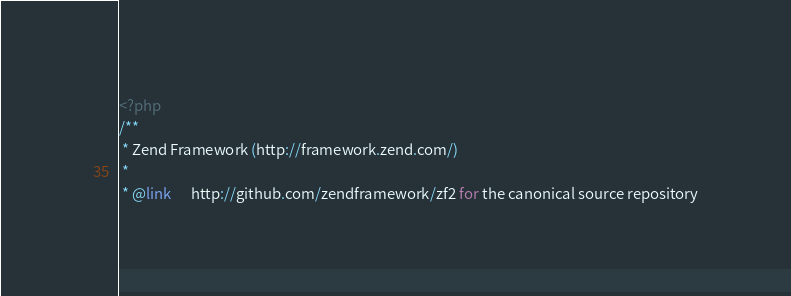<code> <loc_0><loc_0><loc_500><loc_500><_PHP_><?php
/**
 * Zend Framework (http://framework.zend.com/)
 *
 * @link      http://github.com/zendframework/zf2 for the canonical source repository</code> 